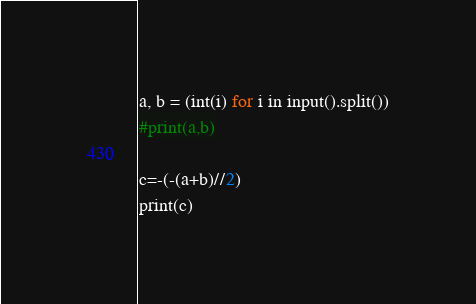<code> <loc_0><loc_0><loc_500><loc_500><_Python_>a, b = (int(i) for i in input().split())
#print(a,b)

c=-(-(a+b)//2)
print(c)</code> 